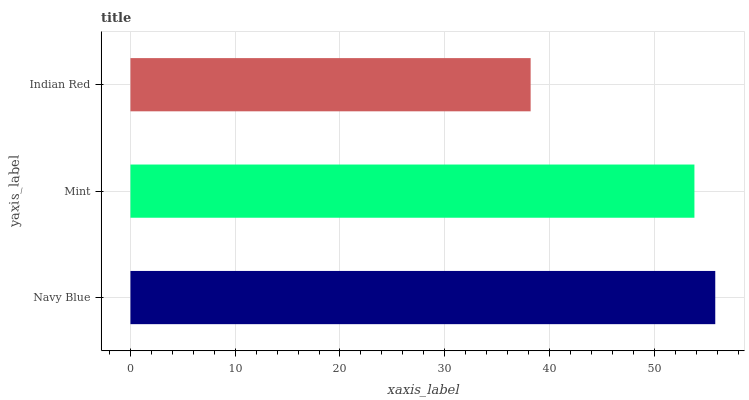Is Indian Red the minimum?
Answer yes or no. Yes. Is Navy Blue the maximum?
Answer yes or no. Yes. Is Mint the minimum?
Answer yes or no. No. Is Mint the maximum?
Answer yes or no. No. Is Navy Blue greater than Mint?
Answer yes or no. Yes. Is Mint less than Navy Blue?
Answer yes or no. Yes. Is Mint greater than Navy Blue?
Answer yes or no. No. Is Navy Blue less than Mint?
Answer yes or no. No. Is Mint the high median?
Answer yes or no. Yes. Is Mint the low median?
Answer yes or no. Yes. Is Navy Blue the high median?
Answer yes or no. No. Is Navy Blue the low median?
Answer yes or no. No. 